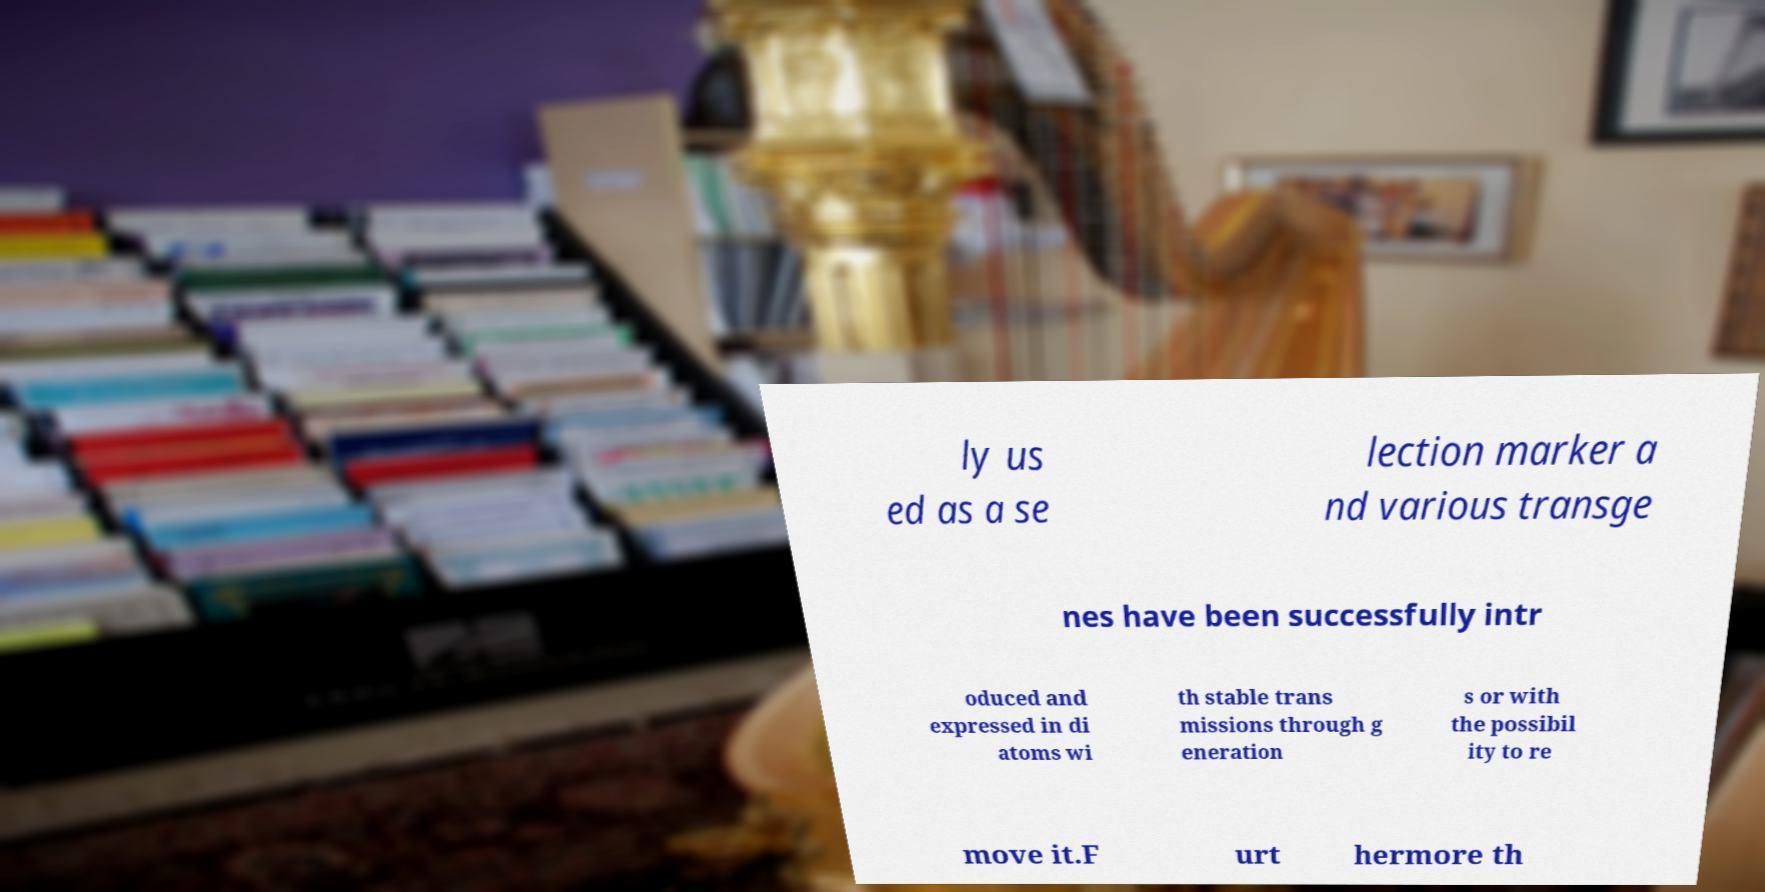There's text embedded in this image that I need extracted. Can you transcribe it verbatim? ly us ed as a se lection marker a nd various transge nes have been successfully intr oduced and expressed in di atoms wi th stable trans missions through g eneration s or with the possibil ity to re move it.F urt hermore th 